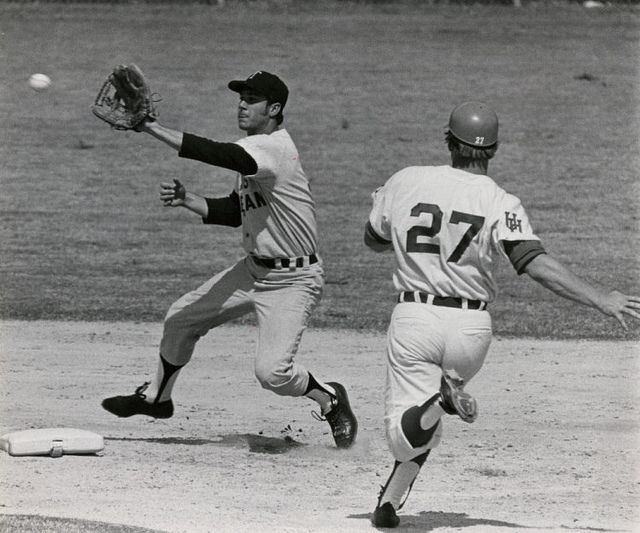<image>Is the pitcher left or right handed? It is ambiguous whether the pitcher is left or right handed. Is the pitcher left or right handed? It is unanswerable whether the pitcher is left or right handed. 